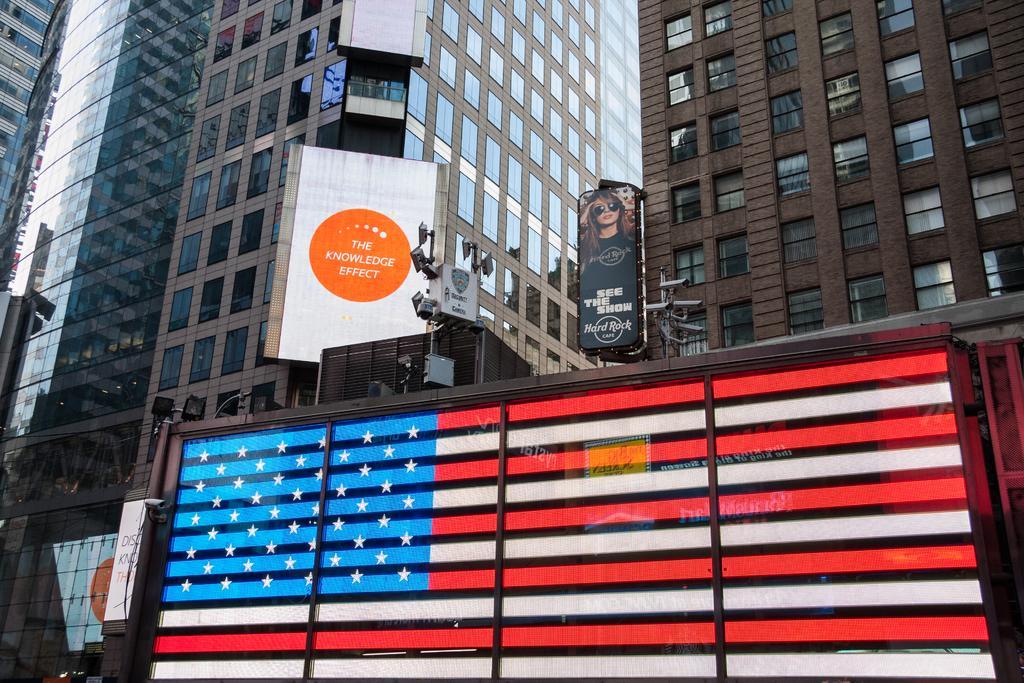How would you summarize this image in a sentence or two? In the image there are many skyscrapers in the back with ad banners on it. 